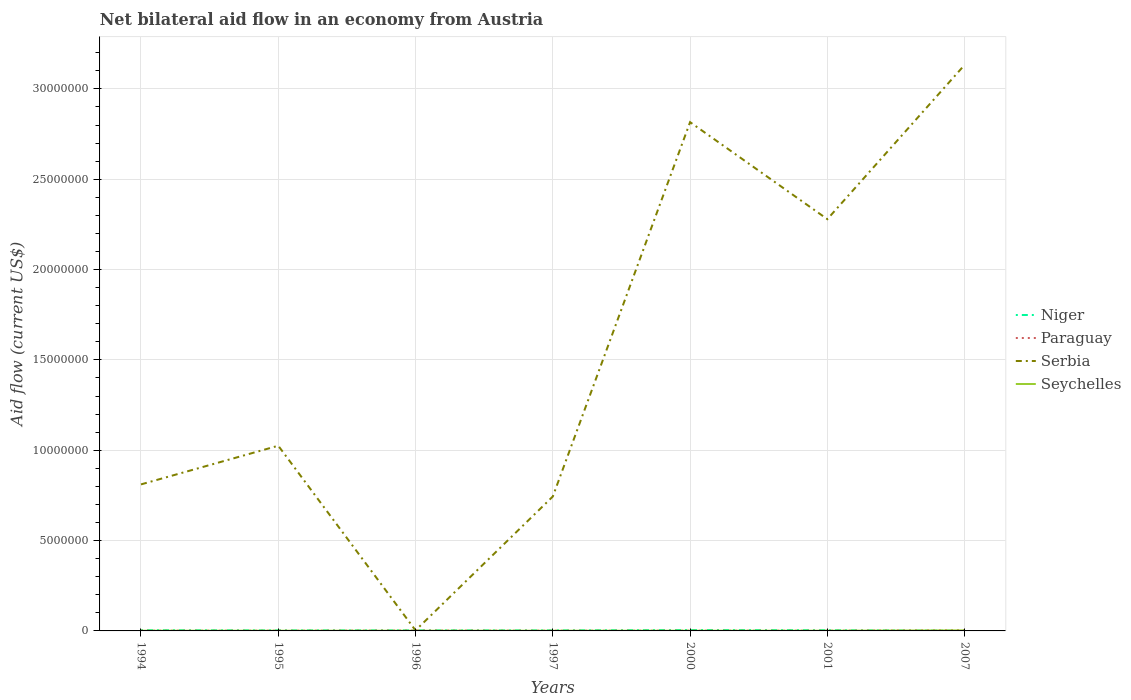How many different coloured lines are there?
Your answer should be compact. 4. Across all years, what is the maximum net bilateral aid flow in Paraguay?
Keep it short and to the point. 10000. What is the total net bilateral aid flow in Paraguay in the graph?
Give a very brief answer. -3.00e+04. What is the difference between the highest and the second highest net bilateral aid flow in Serbia?
Ensure brevity in your answer.  3.13e+07. Is the net bilateral aid flow in Serbia strictly greater than the net bilateral aid flow in Seychelles over the years?
Your answer should be very brief. No. How many years are there in the graph?
Your response must be concise. 7. Are the values on the major ticks of Y-axis written in scientific E-notation?
Offer a very short reply. No. Does the graph contain any zero values?
Make the answer very short. No. Does the graph contain grids?
Give a very brief answer. Yes. Where does the legend appear in the graph?
Your answer should be very brief. Center right. How are the legend labels stacked?
Make the answer very short. Vertical. What is the title of the graph?
Your answer should be compact. Net bilateral aid flow in an economy from Austria. What is the label or title of the X-axis?
Give a very brief answer. Years. What is the Aid flow (current US$) of Niger in 1994?
Your answer should be compact. 4.00e+04. What is the Aid flow (current US$) in Paraguay in 1994?
Your response must be concise. 10000. What is the Aid flow (current US$) of Serbia in 1994?
Provide a short and direct response. 8.11e+06. What is the Aid flow (current US$) in Niger in 1995?
Your answer should be compact. 3.00e+04. What is the Aid flow (current US$) of Serbia in 1995?
Your answer should be compact. 1.02e+07. What is the Aid flow (current US$) of Seychelles in 1995?
Give a very brief answer. 10000. What is the Aid flow (current US$) of Serbia in 1996?
Ensure brevity in your answer.  3.00e+04. What is the Aid flow (current US$) of Seychelles in 1996?
Make the answer very short. 10000. What is the Aid flow (current US$) in Paraguay in 1997?
Your response must be concise. 10000. What is the Aid flow (current US$) in Serbia in 1997?
Provide a succinct answer. 7.44e+06. What is the Aid flow (current US$) in Niger in 2000?
Ensure brevity in your answer.  5.00e+04. What is the Aid flow (current US$) of Paraguay in 2000?
Provide a succinct answer. 10000. What is the Aid flow (current US$) in Serbia in 2000?
Your answer should be very brief. 2.82e+07. What is the Aid flow (current US$) in Seychelles in 2000?
Give a very brief answer. 10000. What is the Aid flow (current US$) in Paraguay in 2001?
Your response must be concise. 10000. What is the Aid flow (current US$) of Serbia in 2001?
Ensure brevity in your answer.  2.28e+07. What is the Aid flow (current US$) of Paraguay in 2007?
Offer a very short reply. 4.00e+04. What is the Aid flow (current US$) of Serbia in 2007?
Your answer should be very brief. 3.13e+07. What is the Aid flow (current US$) of Seychelles in 2007?
Keep it short and to the point. 3.00e+04. Across all years, what is the maximum Aid flow (current US$) in Paraguay?
Ensure brevity in your answer.  4.00e+04. Across all years, what is the maximum Aid flow (current US$) of Serbia?
Keep it short and to the point. 3.13e+07. Across all years, what is the maximum Aid flow (current US$) of Seychelles?
Your response must be concise. 3.00e+04. What is the total Aid flow (current US$) in Serbia in the graph?
Offer a very short reply. 1.08e+08. What is the total Aid flow (current US$) in Seychelles in the graph?
Provide a succinct answer. 9.00e+04. What is the difference between the Aid flow (current US$) in Serbia in 1994 and that in 1995?
Provide a short and direct response. -2.14e+06. What is the difference between the Aid flow (current US$) in Seychelles in 1994 and that in 1995?
Make the answer very short. 0. What is the difference between the Aid flow (current US$) in Paraguay in 1994 and that in 1996?
Provide a short and direct response. -10000. What is the difference between the Aid flow (current US$) of Serbia in 1994 and that in 1996?
Give a very brief answer. 8.08e+06. What is the difference between the Aid flow (current US$) in Niger in 1994 and that in 1997?
Offer a terse response. 10000. What is the difference between the Aid flow (current US$) of Serbia in 1994 and that in 1997?
Ensure brevity in your answer.  6.70e+05. What is the difference between the Aid flow (current US$) of Seychelles in 1994 and that in 1997?
Your answer should be compact. 0. What is the difference between the Aid flow (current US$) in Niger in 1994 and that in 2000?
Keep it short and to the point. -10000. What is the difference between the Aid flow (current US$) of Paraguay in 1994 and that in 2000?
Make the answer very short. 0. What is the difference between the Aid flow (current US$) of Serbia in 1994 and that in 2000?
Ensure brevity in your answer.  -2.00e+07. What is the difference between the Aid flow (current US$) of Seychelles in 1994 and that in 2000?
Make the answer very short. 0. What is the difference between the Aid flow (current US$) in Niger in 1994 and that in 2001?
Provide a succinct answer. 0. What is the difference between the Aid flow (current US$) in Paraguay in 1994 and that in 2001?
Give a very brief answer. 0. What is the difference between the Aid flow (current US$) of Serbia in 1994 and that in 2001?
Your answer should be compact. -1.47e+07. What is the difference between the Aid flow (current US$) of Seychelles in 1994 and that in 2001?
Provide a short and direct response. 0. What is the difference between the Aid flow (current US$) in Niger in 1994 and that in 2007?
Keep it short and to the point. 3.00e+04. What is the difference between the Aid flow (current US$) in Serbia in 1994 and that in 2007?
Offer a terse response. -2.32e+07. What is the difference between the Aid flow (current US$) of Seychelles in 1994 and that in 2007?
Your response must be concise. -2.00e+04. What is the difference between the Aid flow (current US$) of Serbia in 1995 and that in 1996?
Your answer should be very brief. 1.02e+07. What is the difference between the Aid flow (current US$) of Serbia in 1995 and that in 1997?
Offer a very short reply. 2.81e+06. What is the difference between the Aid flow (current US$) of Seychelles in 1995 and that in 1997?
Keep it short and to the point. 0. What is the difference between the Aid flow (current US$) in Niger in 1995 and that in 2000?
Offer a very short reply. -2.00e+04. What is the difference between the Aid flow (current US$) of Paraguay in 1995 and that in 2000?
Provide a short and direct response. 0. What is the difference between the Aid flow (current US$) of Serbia in 1995 and that in 2000?
Provide a succinct answer. -1.79e+07. What is the difference between the Aid flow (current US$) of Seychelles in 1995 and that in 2000?
Your response must be concise. 0. What is the difference between the Aid flow (current US$) of Niger in 1995 and that in 2001?
Provide a short and direct response. -10000. What is the difference between the Aid flow (current US$) of Paraguay in 1995 and that in 2001?
Keep it short and to the point. 0. What is the difference between the Aid flow (current US$) of Serbia in 1995 and that in 2001?
Offer a very short reply. -1.25e+07. What is the difference between the Aid flow (current US$) in Seychelles in 1995 and that in 2001?
Provide a short and direct response. 0. What is the difference between the Aid flow (current US$) of Paraguay in 1995 and that in 2007?
Offer a terse response. -3.00e+04. What is the difference between the Aid flow (current US$) of Serbia in 1995 and that in 2007?
Offer a terse response. -2.11e+07. What is the difference between the Aid flow (current US$) of Seychelles in 1995 and that in 2007?
Provide a succinct answer. -2.00e+04. What is the difference between the Aid flow (current US$) in Niger in 1996 and that in 1997?
Your answer should be compact. 0. What is the difference between the Aid flow (current US$) in Serbia in 1996 and that in 1997?
Keep it short and to the point. -7.41e+06. What is the difference between the Aid flow (current US$) in Seychelles in 1996 and that in 1997?
Keep it short and to the point. 0. What is the difference between the Aid flow (current US$) of Paraguay in 1996 and that in 2000?
Provide a succinct answer. 10000. What is the difference between the Aid flow (current US$) of Serbia in 1996 and that in 2000?
Offer a terse response. -2.81e+07. What is the difference between the Aid flow (current US$) in Paraguay in 1996 and that in 2001?
Your answer should be very brief. 10000. What is the difference between the Aid flow (current US$) in Serbia in 1996 and that in 2001?
Offer a terse response. -2.28e+07. What is the difference between the Aid flow (current US$) of Seychelles in 1996 and that in 2001?
Give a very brief answer. 0. What is the difference between the Aid flow (current US$) in Serbia in 1996 and that in 2007?
Ensure brevity in your answer.  -3.13e+07. What is the difference between the Aid flow (current US$) in Serbia in 1997 and that in 2000?
Provide a short and direct response. -2.07e+07. What is the difference between the Aid flow (current US$) of Seychelles in 1997 and that in 2000?
Offer a very short reply. 0. What is the difference between the Aid flow (current US$) of Serbia in 1997 and that in 2001?
Ensure brevity in your answer.  -1.54e+07. What is the difference between the Aid flow (current US$) of Niger in 1997 and that in 2007?
Your answer should be compact. 2.00e+04. What is the difference between the Aid flow (current US$) in Paraguay in 1997 and that in 2007?
Give a very brief answer. -3.00e+04. What is the difference between the Aid flow (current US$) in Serbia in 1997 and that in 2007?
Keep it short and to the point. -2.39e+07. What is the difference between the Aid flow (current US$) of Serbia in 2000 and that in 2001?
Your answer should be compact. 5.37e+06. What is the difference between the Aid flow (current US$) of Seychelles in 2000 and that in 2001?
Offer a terse response. 0. What is the difference between the Aid flow (current US$) of Niger in 2000 and that in 2007?
Ensure brevity in your answer.  4.00e+04. What is the difference between the Aid flow (current US$) of Serbia in 2000 and that in 2007?
Make the answer very short. -3.17e+06. What is the difference between the Aid flow (current US$) in Niger in 2001 and that in 2007?
Your response must be concise. 3.00e+04. What is the difference between the Aid flow (current US$) of Serbia in 2001 and that in 2007?
Your response must be concise. -8.54e+06. What is the difference between the Aid flow (current US$) of Seychelles in 2001 and that in 2007?
Give a very brief answer. -2.00e+04. What is the difference between the Aid flow (current US$) of Niger in 1994 and the Aid flow (current US$) of Serbia in 1995?
Your answer should be compact. -1.02e+07. What is the difference between the Aid flow (current US$) of Niger in 1994 and the Aid flow (current US$) of Seychelles in 1995?
Your answer should be compact. 3.00e+04. What is the difference between the Aid flow (current US$) of Paraguay in 1994 and the Aid flow (current US$) of Serbia in 1995?
Offer a terse response. -1.02e+07. What is the difference between the Aid flow (current US$) in Paraguay in 1994 and the Aid flow (current US$) in Seychelles in 1995?
Give a very brief answer. 0. What is the difference between the Aid flow (current US$) of Serbia in 1994 and the Aid flow (current US$) of Seychelles in 1995?
Offer a terse response. 8.10e+06. What is the difference between the Aid flow (current US$) of Niger in 1994 and the Aid flow (current US$) of Paraguay in 1996?
Offer a very short reply. 2.00e+04. What is the difference between the Aid flow (current US$) of Niger in 1994 and the Aid flow (current US$) of Serbia in 1996?
Offer a terse response. 10000. What is the difference between the Aid flow (current US$) in Niger in 1994 and the Aid flow (current US$) in Seychelles in 1996?
Your answer should be very brief. 3.00e+04. What is the difference between the Aid flow (current US$) of Paraguay in 1994 and the Aid flow (current US$) of Serbia in 1996?
Provide a succinct answer. -2.00e+04. What is the difference between the Aid flow (current US$) in Paraguay in 1994 and the Aid flow (current US$) in Seychelles in 1996?
Your answer should be very brief. 0. What is the difference between the Aid flow (current US$) in Serbia in 1994 and the Aid flow (current US$) in Seychelles in 1996?
Your answer should be compact. 8.10e+06. What is the difference between the Aid flow (current US$) in Niger in 1994 and the Aid flow (current US$) in Paraguay in 1997?
Give a very brief answer. 3.00e+04. What is the difference between the Aid flow (current US$) of Niger in 1994 and the Aid flow (current US$) of Serbia in 1997?
Give a very brief answer. -7.40e+06. What is the difference between the Aid flow (current US$) of Paraguay in 1994 and the Aid flow (current US$) of Serbia in 1997?
Give a very brief answer. -7.43e+06. What is the difference between the Aid flow (current US$) in Serbia in 1994 and the Aid flow (current US$) in Seychelles in 1997?
Offer a very short reply. 8.10e+06. What is the difference between the Aid flow (current US$) in Niger in 1994 and the Aid flow (current US$) in Serbia in 2000?
Make the answer very short. -2.81e+07. What is the difference between the Aid flow (current US$) of Paraguay in 1994 and the Aid flow (current US$) of Serbia in 2000?
Provide a short and direct response. -2.82e+07. What is the difference between the Aid flow (current US$) in Paraguay in 1994 and the Aid flow (current US$) in Seychelles in 2000?
Make the answer very short. 0. What is the difference between the Aid flow (current US$) of Serbia in 1994 and the Aid flow (current US$) of Seychelles in 2000?
Make the answer very short. 8.10e+06. What is the difference between the Aid flow (current US$) in Niger in 1994 and the Aid flow (current US$) in Serbia in 2001?
Offer a terse response. -2.28e+07. What is the difference between the Aid flow (current US$) of Paraguay in 1994 and the Aid flow (current US$) of Serbia in 2001?
Offer a very short reply. -2.28e+07. What is the difference between the Aid flow (current US$) of Paraguay in 1994 and the Aid flow (current US$) of Seychelles in 2001?
Keep it short and to the point. 0. What is the difference between the Aid flow (current US$) of Serbia in 1994 and the Aid flow (current US$) of Seychelles in 2001?
Ensure brevity in your answer.  8.10e+06. What is the difference between the Aid flow (current US$) in Niger in 1994 and the Aid flow (current US$) in Paraguay in 2007?
Your answer should be compact. 0. What is the difference between the Aid flow (current US$) in Niger in 1994 and the Aid flow (current US$) in Serbia in 2007?
Your response must be concise. -3.13e+07. What is the difference between the Aid flow (current US$) in Niger in 1994 and the Aid flow (current US$) in Seychelles in 2007?
Your response must be concise. 10000. What is the difference between the Aid flow (current US$) in Paraguay in 1994 and the Aid flow (current US$) in Serbia in 2007?
Provide a short and direct response. -3.13e+07. What is the difference between the Aid flow (current US$) of Serbia in 1994 and the Aid flow (current US$) of Seychelles in 2007?
Your answer should be compact. 8.08e+06. What is the difference between the Aid flow (current US$) of Niger in 1995 and the Aid flow (current US$) of Paraguay in 1996?
Your answer should be compact. 10000. What is the difference between the Aid flow (current US$) in Niger in 1995 and the Aid flow (current US$) in Serbia in 1996?
Offer a very short reply. 0. What is the difference between the Aid flow (current US$) in Paraguay in 1995 and the Aid flow (current US$) in Serbia in 1996?
Offer a terse response. -2.00e+04. What is the difference between the Aid flow (current US$) of Serbia in 1995 and the Aid flow (current US$) of Seychelles in 1996?
Ensure brevity in your answer.  1.02e+07. What is the difference between the Aid flow (current US$) in Niger in 1995 and the Aid flow (current US$) in Paraguay in 1997?
Keep it short and to the point. 2.00e+04. What is the difference between the Aid flow (current US$) in Niger in 1995 and the Aid flow (current US$) in Serbia in 1997?
Ensure brevity in your answer.  -7.41e+06. What is the difference between the Aid flow (current US$) in Paraguay in 1995 and the Aid flow (current US$) in Serbia in 1997?
Give a very brief answer. -7.43e+06. What is the difference between the Aid flow (current US$) in Paraguay in 1995 and the Aid flow (current US$) in Seychelles in 1997?
Give a very brief answer. 0. What is the difference between the Aid flow (current US$) in Serbia in 1995 and the Aid flow (current US$) in Seychelles in 1997?
Keep it short and to the point. 1.02e+07. What is the difference between the Aid flow (current US$) in Niger in 1995 and the Aid flow (current US$) in Serbia in 2000?
Your answer should be compact. -2.81e+07. What is the difference between the Aid flow (current US$) of Paraguay in 1995 and the Aid flow (current US$) of Serbia in 2000?
Provide a succinct answer. -2.82e+07. What is the difference between the Aid flow (current US$) in Serbia in 1995 and the Aid flow (current US$) in Seychelles in 2000?
Your answer should be very brief. 1.02e+07. What is the difference between the Aid flow (current US$) of Niger in 1995 and the Aid flow (current US$) of Serbia in 2001?
Your answer should be very brief. -2.28e+07. What is the difference between the Aid flow (current US$) of Paraguay in 1995 and the Aid flow (current US$) of Serbia in 2001?
Make the answer very short. -2.28e+07. What is the difference between the Aid flow (current US$) of Serbia in 1995 and the Aid flow (current US$) of Seychelles in 2001?
Your response must be concise. 1.02e+07. What is the difference between the Aid flow (current US$) of Niger in 1995 and the Aid flow (current US$) of Serbia in 2007?
Provide a short and direct response. -3.13e+07. What is the difference between the Aid flow (current US$) of Paraguay in 1995 and the Aid flow (current US$) of Serbia in 2007?
Provide a short and direct response. -3.13e+07. What is the difference between the Aid flow (current US$) of Paraguay in 1995 and the Aid flow (current US$) of Seychelles in 2007?
Keep it short and to the point. -2.00e+04. What is the difference between the Aid flow (current US$) in Serbia in 1995 and the Aid flow (current US$) in Seychelles in 2007?
Offer a very short reply. 1.02e+07. What is the difference between the Aid flow (current US$) of Niger in 1996 and the Aid flow (current US$) of Serbia in 1997?
Give a very brief answer. -7.41e+06. What is the difference between the Aid flow (current US$) of Paraguay in 1996 and the Aid flow (current US$) of Serbia in 1997?
Your answer should be very brief. -7.42e+06. What is the difference between the Aid flow (current US$) of Niger in 1996 and the Aid flow (current US$) of Paraguay in 2000?
Your response must be concise. 2.00e+04. What is the difference between the Aid flow (current US$) in Niger in 1996 and the Aid flow (current US$) in Serbia in 2000?
Ensure brevity in your answer.  -2.81e+07. What is the difference between the Aid flow (current US$) of Niger in 1996 and the Aid flow (current US$) of Seychelles in 2000?
Keep it short and to the point. 2.00e+04. What is the difference between the Aid flow (current US$) in Paraguay in 1996 and the Aid flow (current US$) in Serbia in 2000?
Provide a short and direct response. -2.81e+07. What is the difference between the Aid flow (current US$) in Paraguay in 1996 and the Aid flow (current US$) in Seychelles in 2000?
Offer a terse response. 10000. What is the difference between the Aid flow (current US$) of Niger in 1996 and the Aid flow (current US$) of Serbia in 2001?
Make the answer very short. -2.28e+07. What is the difference between the Aid flow (current US$) in Niger in 1996 and the Aid flow (current US$) in Seychelles in 2001?
Your response must be concise. 2.00e+04. What is the difference between the Aid flow (current US$) of Paraguay in 1996 and the Aid flow (current US$) of Serbia in 2001?
Offer a very short reply. -2.28e+07. What is the difference between the Aid flow (current US$) in Serbia in 1996 and the Aid flow (current US$) in Seychelles in 2001?
Your answer should be very brief. 2.00e+04. What is the difference between the Aid flow (current US$) in Niger in 1996 and the Aid flow (current US$) in Serbia in 2007?
Provide a short and direct response. -3.13e+07. What is the difference between the Aid flow (current US$) in Niger in 1996 and the Aid flow (current US$) in Seychelles in 2007?
Provide a succinct answer. 0. What is the difference between the Aid flow (current US$) in Paraguay in 1996 and the Aid flow (current US$) in Serbia in 2007?
Make the answer very short. -3.13e+07. What is the difference between the Aid flow (current US$) of Paraguay in 1996 and the Aid flow (current US$) of Seychelles in 2007?
Your answer should be compact. -10000. What is the difference between the Aid flow (current US$) in Serbia in 1996 and the Aid flow (current US$) in Seychelles in 2007?
Provide a short and direct response. 0. What is the difference between the Aid flow (current US$) of Niger in 1997 and the Aid flow (current US$) of Paraguay in 2000?
Give a very brief answer. 2.00e+04. What is the difference between the Aid flow (current US$) in Niger in 1997 and the Aid flow (current US$) in Serbia in 2000?
Provide a short and direct response. -2.81e+07. What is the difference between the Aid flow (current US$) of Niger in 1997 and the Aid flow (current US$) of Seychelles in 2000?
Provide a succinct answer. 2.00e+04. What is the difference between the Aid flow (current US$) in Paraguay in 1997 and the Aid flow (current US$) in Serbia in 2000?
Offer a terse response. -2.82e+07. What is the difference between the Aid flow (current US$) in Paraguay in 1997 and the Aid flow (current US$) in Seychelles in 2000?
Ensure brevity in your answer.  0. What is the difference between the Aid flow (current US$) in Serbia in 1997 and the Aid flow (current US$) in Seychelles in 2000?
Make the answer very short. 7.43e+06. What is the difference between the Aid flow (current US$) of Niger in 1997 and the Aid flow (current US$) of Serbia in 2001?
Give a very brief answer. -2.28e+07. What is the difference between the Aid flow (current US$) in Niger in 1997 and the Aid flow (current US$) in Seychelles in 2001?
Offer a very short reply. 2.00e+04. What is the difference between the Aid flow (current US$) of Paraguay in 1997 and the Aid flow (current US$) of Serbia in 2001?
Your answer should be compact. -2.28e+07. What is the difference between the Aid flow (current US$) of Serbia in 1997 and the Aid flow (current US$) of Seychelles in 2001?
Provide a succinct answer. 7.43e+06. What is the difference between the Aid flow (current US$) of Niger in 1997 and the Aid flow (current US$) of Paraguay in 2007?
Your response must be concise. -10000. What is the difference between the Aid flow (current US$) in Niger in 1997 and the Aid flow (current US$) in Serbia in 2007?
Offer a very short reply. -3.13e+07. What is the difference between the Aid flow (current US$) of Paraguay in 1997 and the Aid flow (current US$) of Serbia in 2007?
Your response must be concise. -3.13e+07. What is the difference between the Aid flow (current US$) in Serbia in 1997 and the Aid flow (current US$) in Seychelles in 2007?
Provide a succinct answer. 7.41e+06. What is the difference between the Aid flow (current US$) of Niger in 2000 and the Aid flow (current US$) of Serbia in 2001?
Offer a very short reply. -2.27e+07. What is the difference between the Aid flow (current US$) of Paraguay in 2000 and the Aid flow (current US$) of Serbia in 2001?
Give a very brief answer. -2.28e+07. What is the difference between the Aid flow (current US$) of Serbia in 2000 and the Aid flow (current US$) of Seychelles in 2001?
Provide a short and direct response. 2.82e+07. What is the difference between the Aid flow (current US$) in Niger in 2000 and the Aid flow (current US$) in Serbia in 2007?
Provide a succinct answer. -3.13e+07. What is the difference between the Aid flow (current US$) in Paraguay in 2000 and the Aid flow (current US$) in Serbia in 2007?
Make the answer very short. -3.13e+07. What is the difference between the Aid flow (current US$) of Serbia in 2000 and the Aid flow (current US$) of Seychelles in 2007?
Offer a terse response. 2.81e+07. What is the difference between the Aid flow (current US$) of Niger in 2001 and the Aid flow (current US$) of Paraguay in 2007?
Provide a short and direct response. 0. What is the difference between the Aid flow (current US$) in Niger in 2001 and the Aid flow (current US$) in Serbia in 2007?
Provide a short and direct response. -3.13e+07. What is the difference between the Aid flow (current US$) of Paraguay in 2001 and the Aid flow (current US$) of Serbia in 2007?
Provide a succinct answer. -3.13e+07. What is the difference between the Aid flow (current US$) in Serbia in 2001 and the Aid flow (current US$) in Seychelles in 2007?
Give a very brief answer. 2.28e+07. What is the average Aid flow (current US$) of Niger per year?
Provide a succinct answer. 3.29e+04. What is the average Aid flow (current US$) of Paraguay per year?
Your response must be concise. 1.57e+04. What is the average Aid flow (current US$) in Serbia per year?
Give a very brief answer. 1.54e+07. What is the average Aid flow (current US$) of Seychelles per year?
Give a very brief answer. 1.29e+04. In the year 1994, what is the difference between the Aid flow (current US$) of Niger and Aid flow (current US$) of Serbia?
Give a very brief answer. -8.07e+06. In the year 1994, what is the difference between the Aid flow (current US$) of Paraguay and Aid flow (current US$) of Serbia?
Give a very brief answer. -8.10e+06. In the year 1994, what is the difference between the Aid flow (current US$) of Serbia and Aid flow (current US$) of Seychelles?
Offer a terse response. 8.10e+06. In the year 1995, what is the difference between the Aid flow (current US$) of Niger and Aid flow (current US$) of Serbia?
Provide a succinct answer. -1.02e+07. In the year 1995, what is the difference between the Aid flow (current US$) in Paraguay and Aid flow (current US$) in Serbia?
Your answer should be very brief. -1.02e+07. In the year 1995, what is the difference between the Aid flow (current US$) in Serbia and Aid flow (current US$) in Seychelles?
Your response must be concise. 1.02e+07. In the year 1996, what is the difference between the Aid flow (current US$) in Niger and Aid flow (current US$) in Serbia?
Your answer should be very brief. 0. In the year 1996, what is the difference between the Aid flow (current US$) of Paraguay and Aid flow (current US$) of Serbia?
Offer a terse response. -10000. In the year 1997, what is the difference between the Aid flow (current US$) in Niger and Aid flow (current US$) in Serbia?
Ensure brevity in your answer.  -7.41e+06. In the year 1997, what is the difference between the Aid flow (current US$) in Niger and Aid flow (current US$) in Seychelles?
Give a very brief answer. 2.00e+04. In the year 1997, what is the difference between the Aid flow (current US$) in Paraguay and Aid flow (current US$) in Serbia?
Your answer should be compact. -7.43e+06. In the year 1997, what is the difference between the Aid flow (current US$) in Serbia and Aid flow (current US$) in Seychelles?
Give a very brief answer. 7.43e+06. In the year 2000, what is the difference between the Aid flow (current US$) in Niger and Aid flow (current US$) in Paraguay?
Give a very brief answer. 4.00e+04. In the year 2000, what is the difference between the Aid flow (current US$) of Niger and Aid flow (current US$) of Serbia?
Your answer should be compact. -2.81e+07. In the year 2000, what is the difference between the Aid flow (current US$) of Paraguay and Aid flow (current US$) of Serbia?
Keep it short and to the point. -2.82e+07. In the year 2000, what is the difference between the Aid flow (current US$) of Serbia and Aid flow (current US$) of Seychelles?
Offer a very short reply. 2.82e+07. In the year 2001, what is the difference between the Aid flow (current US$) in Niger and Aid flow (current US$) in Paraguay?
Your answer should be very brief. 3.00e+04. In the year 2001, what is the difference between the Aid flow (current US$) of Niger and Aid flow (current US$) of Serbia?
Keep it short and to the point. -2.28e+07. In the year 2001, what is the difference between the Aid flow (current US$) of Niger and Aid flow (current US$) of Seychelles?
Offer a terse response. 3.00e+04. In the year 2001, what is the difference between the Aid flow (current US$) in Paraguay and Aid flow (current US$) in Serbia?
Your answer should be very brief. -2.28e+07. In the year 2001, what is the difference between the Aid flow (current US$) in Serbia and Aid flow (current US$) in Seychelles?
Provide a succinct answer. 2.28e+07. In the year 2007, what is the difference between the Aid flow (current US$) of Niger and Aid flow (current US$) of Paraguay?
Your response must be concise. -3.00e+04. In the year 2007, what is the difference between the Aid flow (current US$) of Niger and Aid flow (current US$) of Serbia?
Ensure brevity in your answer.  -3.13e+07. In the year 2007, what is the difference between the Aid flow (current US$) in Paraguay and Aid flow (current US$) in Serbia?
Offer a very short reply. -3.13e+07. In the year 2007, what is the difference between the Aid flow (current US$) in Serbia and Aid flow (current US$) in Seychelles?
Make the answer very short. 3.13e+07. What is the ratio of the Aid flow (current US$) in Niger in 1994 to that in 1995?
Ensure brevity in your answer.  1.33. What is the ratio of the Aid flow (current US$) in Serbia in 1994 to that in 1995?
Make the answer very short. 0.79. What is the ratio of the Aid flow (current US$) in Seychelles in 1994 to that in 1995?
Keep it short and to the point. 1. What is the ratio of the Aid flow (current US$) in Serbia in 1994 to that in 1996?
Provide a short and direct response. 270.33. What is the ratio of the Aid flow (current US$) in Seychelles in 1994 to that in 1996?
Your answer should be very brief. 1. What is the ratio of the Aid flow (current US$) in Paraguay in 1994 to that in 1997?
Provide a short and direct response. 1. What is the ratio of the Aid flow (current US$) in Serbia in 1994 to that in 1997?
Ensure brevity in your answer.  1.09. What is the ratio of the Aid flow (current US$) in Seychelles in 1994 to that in 1997?
Provide a succinct answer. 1. What is the ratio of the Aid flow (current US$) in Niger in 1994 to that in 2000?
Provide a succinct answer. 0.8. What is the ratio of the Aid flow (current US$) in Serbia in 1994 to that in 2000?
Offer a terse response. 0.29. What is the ratio of the Aid flow (current US$) in Serbia in 1994 to that in 2001?
Make the answer very short. 0.36. What is the ratio of the Aid flow (current US$) of Seychelles in 1994 to that in 2001?
Provide a short and direct response. 1. What is the ratio of the Aid flow (current US$) of Niger in 1994 to that in 2007?
Provide a short and direct response. 4. What is the ratio of the Aid flow (current US$) of Serbia in 1994 to that in 2007?
Make the answer very short. 0.26. What is the ratio of the Aid flow (current US$) of Seychelles in 1994 to that in 2007?
Your response must be concise. 0.33. What is the ratio of the Aid flow (current US$) in Paraguay in 1995 to that in 1996?
Keep it short and to the point. 0.5. What is the ratio of the Aid flow (current US$) in Serbia in 1995 to that in 1996?
Your answer should be compact. 341.67. What is the ratio of the Aid flow (current US$) of Paraguay in 1995 to that in 1997?
Offer a very short reply. 1. What is the ratio of the Aid flow (current US$) of Serbia in 1995 to that in 1997?
Your answer should be compact. 1.38. What is the ratio of the Aid flow (current US$) of Seychelles in 1995 to that in 1997?
Provide a succinct answer. 1. What is the ratio of the Aid flow (current US$) of Niger in 1995 to that in 2000?
Your answer should be compact. 0.6. What is the ratio of the Aid flow (current US$) in Paraguay in 1995 to that in 2000?
Make the answer very short. 1. What is the ratio of the Aid flow (current US$) in Serbia in 1995 to that in 2000?
Provide a succinct answer. 0.36. What is the ratio of the Aid flow (current US$) in Seychelles in 1995 to that in 2000?
Provide a succinct answer. 1. What is the ratio of the Aid flow (current US$) in Niger in 1995 to that in 2001?
Your response must be concise. 0.75. What is the ratio of the Aid flow (current US$) in Paraguay in 1995 to that in 2001?
Ensure brevity in your answer.  1. What is the ratio of the Aid flow (current US$) in Serbia in 1995 to that in 2001?
Provide a succinct answer. 0.45. What is the ratio of the Aid flow (current US$) of Seychelles in 1995 to that in 2001?
Keep it short and to the point. 1. What is the ratio of the Aid flow (current US$) in Niger in 1995 to that in 2007?
Your response must be concise. 3. What is the ratio of the Aid flow (current US$) in Serbia in 1995 to that in 2007?
Ensure brevity in your answer.  0.33. What is the ratio of the Aid flow (current US$) of Seychelles in 1995 to that in 2007?
Your answer should be very brief. 0.33. What is the ratio of the Aid flow (current US$) of Serbia in 1996 to that in 1997?
Make the answer very short. 0. What is the ratio of the Aid flow (current US$) of Paraguay in 1996 to that in 2000?
Keep it short and to the point. 2. What is the ratio of the Aid flow (current US$) of Serbia in 1996 to that in 2000?
Your response must be concise. 0. What is the ratio of the Aid flow (current US$) in Seychelles in 1996 to that in 2000?
Give a very brief answer. 1. What is the ratio of the Aid flow (current US$) in Serbia in 1996 to that in 2001?
Offer a terse response. 0. What is the ratio of the Aid flow (current US$) in Seychelles in 1996 to that in 2001?
Give a very brief answer. 1. What is the ratio of the Aid flow (current US$) of Serbia in 1996 to that in 2007?
Offer a very short reply. 0. What is the ratio of the Aid flow (current US$) of Niger in 1997 to that in 2000?
Give a very brief answer. 0.6. What is the ratio of the Aid flow (current US$) in Paraguay in 1997 to that in 2000?
Keep it short and to the point. 1. What is the ratio of the Aid flow (current US$) in Serbia in 1997 to that in 2000?
Offer a very short reply. 0.26. What is the ratio of the Aid flow (current US$) in Seychelles in 1997 to that in 2000?
Offer a terse response. 1. What is the ratio of the Aid flow (current US$) in Niger in 1997 to that in 2001?
Offer a very short reply. 0.75. What is the ratio of the Aid flow (current US$) of Serbia in 1997 to that in 2001?
Your answer should be very brief. 0.33. What is the ratio of the Aid flow (current US$) in Serbia in 1997 to that in 2007?
Keep it short and to the point. 0.24. What is the ratio of the Aid flow (current US$) of Paraguay in 2000 to that in 2001?
Offer a very short reply. 1. What is the ratio of the Aid flow (current US$) in Serbia in 2000 to that in 2001?
Offer a very short reply. 1.24. What is the ratio of the Aid flow (current US$) in Niger in 2000 to that in 2007?
Make the answer very short. 5. What is the ratio of the Aid flow (current US$) of Serbia in 2000 to that in 2007?
Your response must be concise. 0.9. What is the ratio of the Aid flow (current US$) in Niger in 2001 to that in 2007?
Ensure brevity in your answer.  4. What is the ratio of the Aid flow (current US$) of Serbia in 2001 to that in 2007?
Provide a succinct answer. 0.73. What is the difference between the highest and the second highest Aid flow (current US$) in Paraguay?
Offer a very short reply. 2.00e+04. What is the difference between the highest and the second highest Aid flow (current US$) in Serbia?
Provide a succinct answer. 3.17e+06. What is the difference between the highest and the second highest Aid flow (current US$) in Seychelles?
Keep it short and to the point. 2.00e+04. What is the difference between the highest and the lowest Aid flow (current US$) in Serbia?
Your response must be concise. 3.13e+07. What is the difference between the highest and the lowest Aid flow (current US$) in Seychelles?
Offer a very short reply. 2.00e+04. 